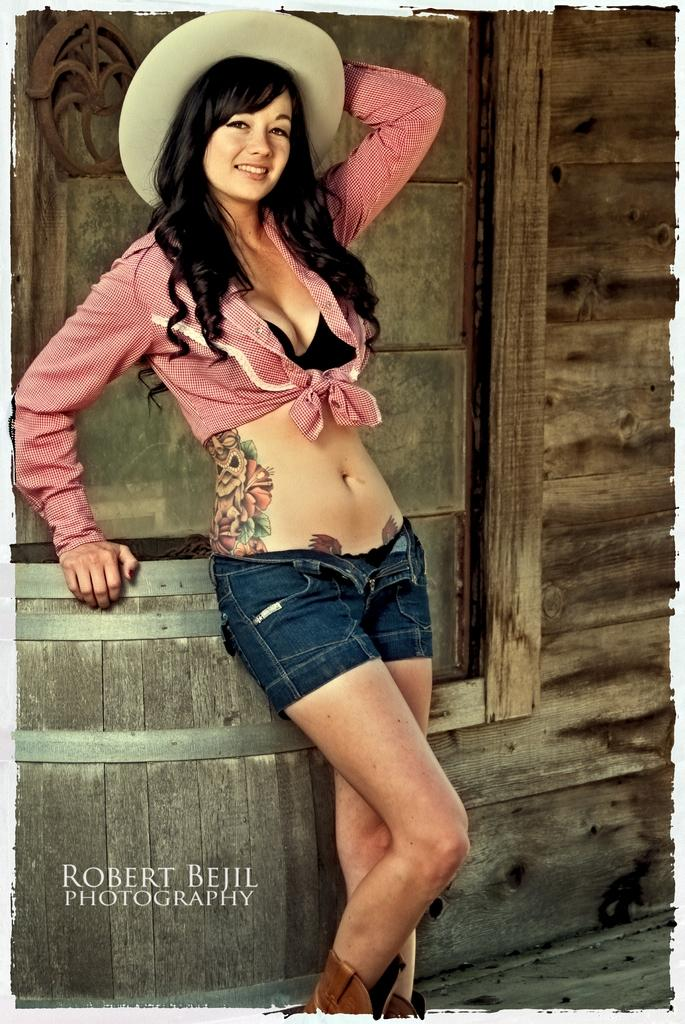What is the main subject of the image? There is a woman standing in the center of the image. What is the woman's expression in the image? The woman is smiling in the image. What can be seen in the background of the image? There is a wooden wall, a barrel, and a watermark in the background of the image. How does the woman compare to the waves in the image? There are no waves present in the image, so it is not possible to make a comparison. 